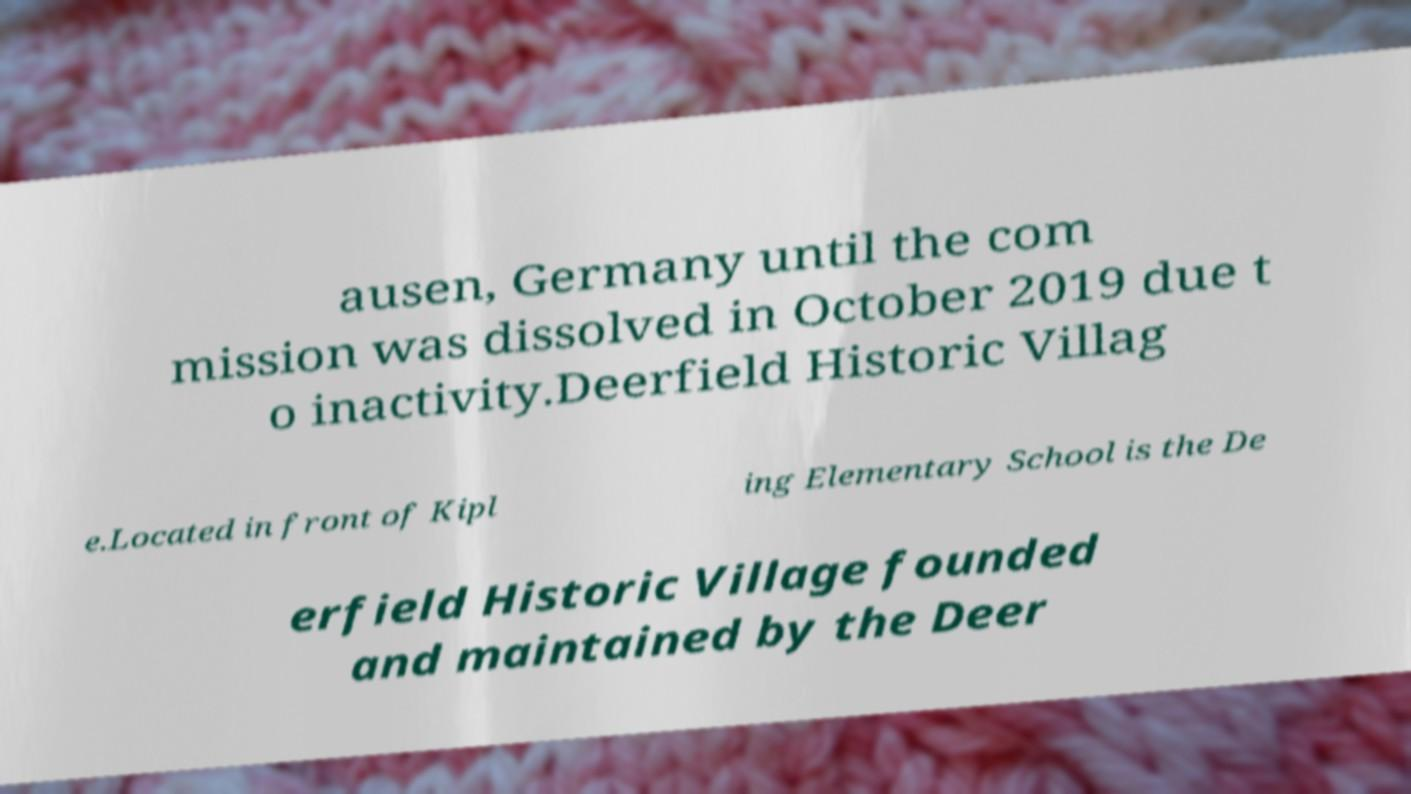Please identify and transcribe the text found in this image. ausen, Germany until the com mission was dissolved in October 2019 due t o inactivity.Deerfield Historic Villag e.Located in front of Kipl ing Elementary School is the De erfield Historic Village founded and maintained by the Deer 